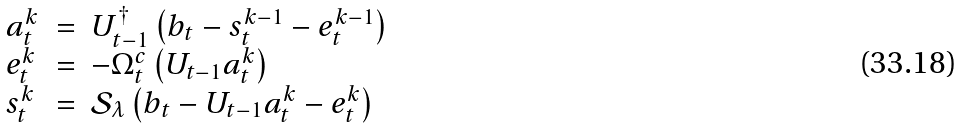<formula> <loc_0><loc_0><loc_500><loc_500>\begin{array} { l l l } a _ { t } ^ { k } & = & U _ { t - 1 } ^ { \dagger } \left ( b _ { t } - s _ { t } ^ { k - 1 } - e _ { t } ^ { k - 1 } \right ) \\ e _ { t } ^ { k } & = & - \Omega _ { t } ^ { c } \left ( U _ { t - 1 } a _ { t } ^ { k } \right ) \\ s _ { t } ^ { k } & = & \mathcal { S } _ { \lambda } \left ( b _ { t } - U _ { t - 1 } a _ { t } ^ { k } - e _ { t } ^ { k } \right ) \\ \end{array}</formula> 